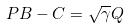<formula> <loc_0><loc_0><loc_500><loc_500>P B - C = \sqrt { \gamma } Q</formula> 